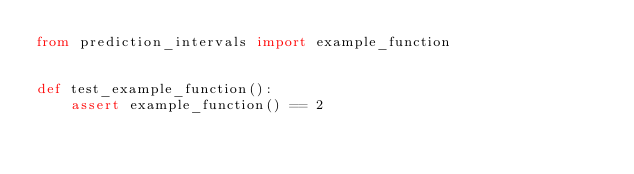<code> <loc_0><loc_0><loc_500><loc_500><_Python_>from prediction_intervals import example_function


def test_example_function():
    assert example_function() == 2
</code> 